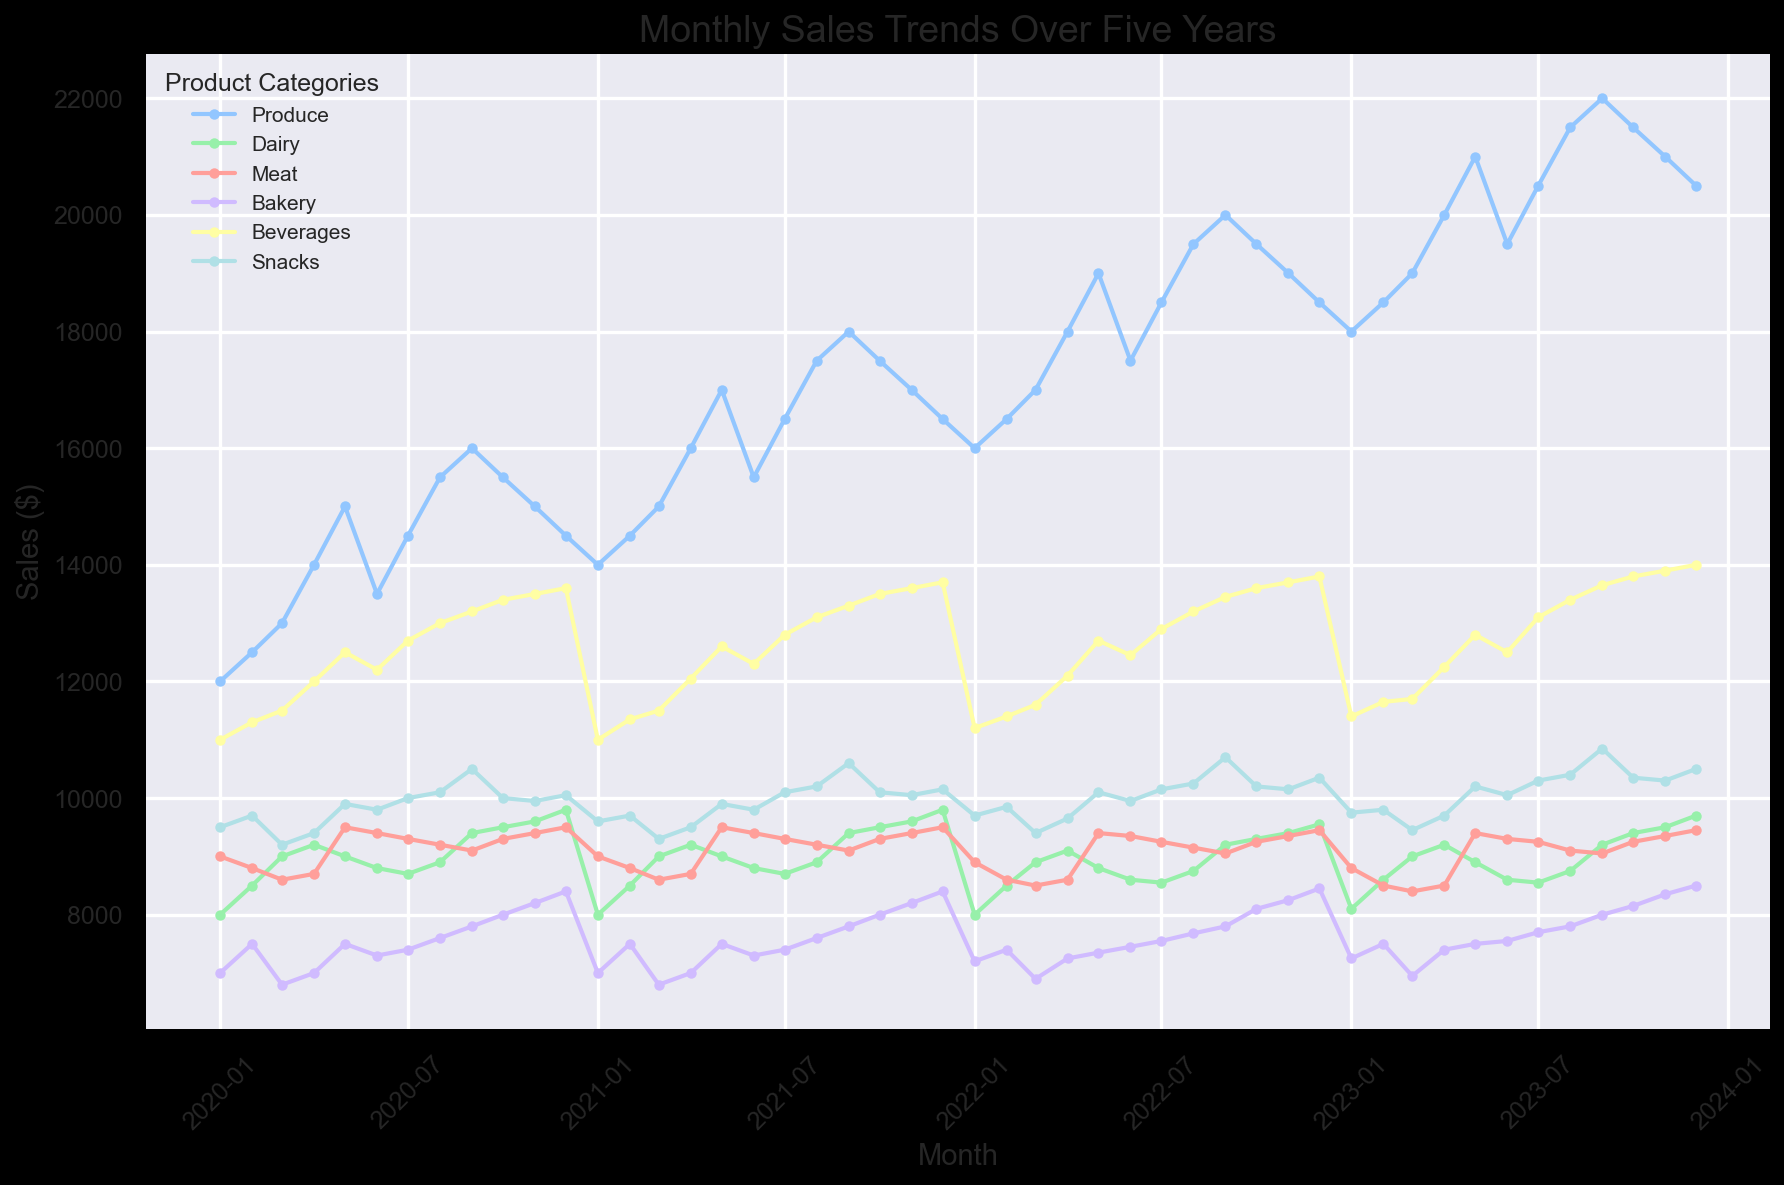What month and year did the Produce category see its highest sales? Observe the highest point on the line corresponding to the Produce category and note its position along the x-axis. The highest point is in September 2023 with a sales value of $22,000.
Answer: September 2023 Which product category had the lowest sales in January 2023 and what was the value? Find the point corresponding to January 2023 for each product category and identify the category with the lowest sales value. Meat had the lowest sales in January 2023 with a value of $8,800.
Answer: Meat, $8,800 Did Dairy sales increase or decrease from January 2020 to December 2023? Look at the beginning and end points of the Dairy category's line. Sales increased from $8,000 in January 2020 to $9,700 in December 2023.
Answer: Increase What is the average sales value for the Beverages category in the year 2021? Note the sales values for the Beverages category for each month in 2021 and calculate their average. The sales values are $11,000, $11,350, $11,500, $12,050, $12,600, $12,300, $12,800, $13,100, $13,300, $13,500, $13,600, $13,700. The sum is $154,450 and the average is $154,450 / 12 = $12,871.
Answer: $12,871 Which product category showed the most stable trend from 2020 to 2023? Examine the fluctuation patterns of the lines for each product category over the period. The Dairy category line appears the most stable with relatively less fluctuation compared to others.
Answer: Dairy In which month did Bakery sales peak in 2022, and what was the value? Identify the highest point on the Bakery category line in 2022 and note its position along the x-axis and its value. Bakery sales peaked in December 2022 with a value of $8,450.
Answer: December 2022, $8,450 Compare the sales trend of Produce and Snacks over the five years. Which one had a more consistent upward trend? Trace the lines for both Produce and Snacks categories from 2020 to 2023. The Produce category shows a more consistent upward trend, while the Snacks category has some fluctuations.
Answer: Produce What was the combined sales for Meat and Beverages in March 2021? Add the sales values for Meat and Beverages in March 2021. Meat sales were $8,600 and Beverages sales were $11,500. The combined sales are $8,600 + $11,500 = $20,100.
Answer: $20,100 How did Bakery sales change from May to June in 2023? Observe the points for Bakery sales in May and June 2023. Bakery sales remained the same at $7,500 in both May and June 2023.
Answer: Same 